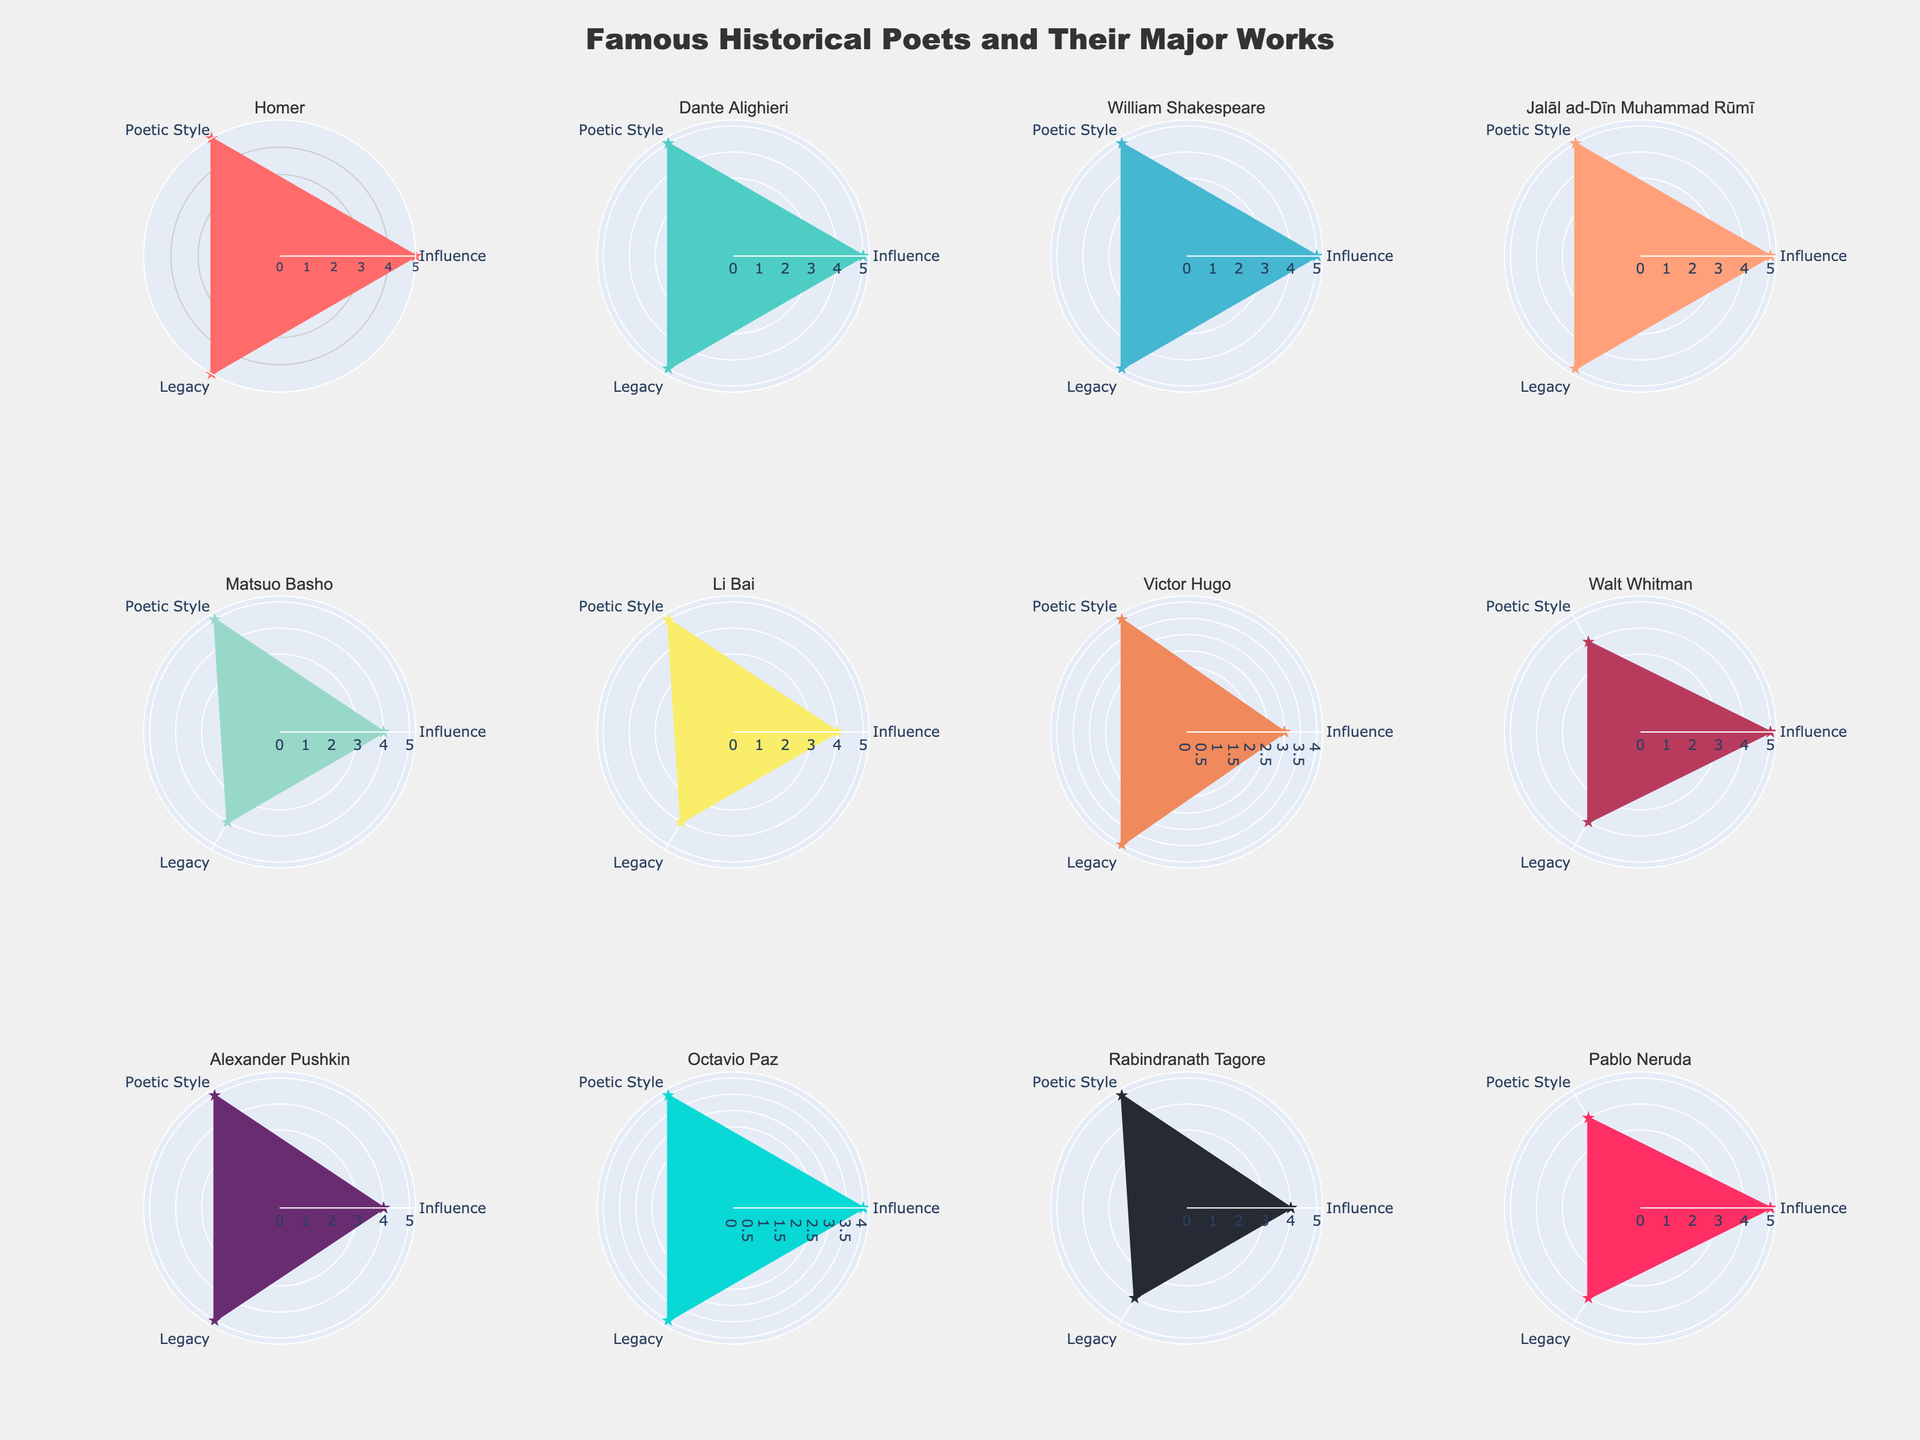what is the title of the figure? The title of the figure is displayed at the top and is the largest text, centralized above all subplots. It indicates the main subject of the visual representation.
Answer: Famous Historical Poets and Their Major Works how many poets are represented in each row of the subplots? Each row of the subplots has an equal distribution of poets. Since there are 3 rows and the total number of poets is 12, each row has 12/3 = 4 poets.
Answer: 4 which poet's radar chart has the color '#6A2C70'? The radar charts are color-coded uniquely per poet. By matching the described color with the visual, one can identify which poet corresponds to that specific color.
Answer: Alexander Pushkin compare the legacy values of Homer and Matsuo Basho. who has a higher value? By examining the radar charts, the 'Legacy' value for each poet needs to be visually compared by their corresponding axis radius. Homer has a full value of 5 while Matsuo Basho has a value of 4.
Answer: Homer list the poets who have a poetic style value of 5. Review each radar chart's 'Poetic Style' axis and note which ones extend fully to the maximum value of 5.
Answer: Homer, Dante Alighieri, William Shakespeare, Jalāl ad-Dīn Muhammad Rūmī, Matsuo Basho, Li Bai, Rabindranath Tagore if you sum up the influence values of poets from the 19th century, what is the total? From the provided data, the poets of the 19th century are Victor Hugo, Walt Whitman, and Alexander Pushkin. Their 'Influence' values are 3, 5, and 4, respectively. Summing these values: 3 + 5 + 4 = 12.
Answer: 12 which country has a poet with the least influence value? The 'Influence' value needs to be checked for each poet, and the country with the least 'Influence' among them should be identified. The lowest is 3, by Victor Hugo from France.
Answer: France how does rabindranath tagore's legacy value compare to pablo neruda's? A direct comparison of the 'Legacy' values in their radar charts shows that both poets have a 'Legacy' value of 4.
Answer: Equal describe the general trend for the 'Poetic Style' attribute across all poets. By analyzing the 'Poetic Style' values on each radar chart, one observes that the majority of the poets have the maximum value of 5, indicating a trend where most poets excel in poetic style.
Answer: Most poets have 5 which era has the most poets represented in this figure? Each radar chart specifies an era. Tallying the poets per era gives insight into which era has the most representatives. The 20th century has three poets: Octavio Paz, Rabindranath Tagore, and Pablo Neruda.
Answer: 20th Century 